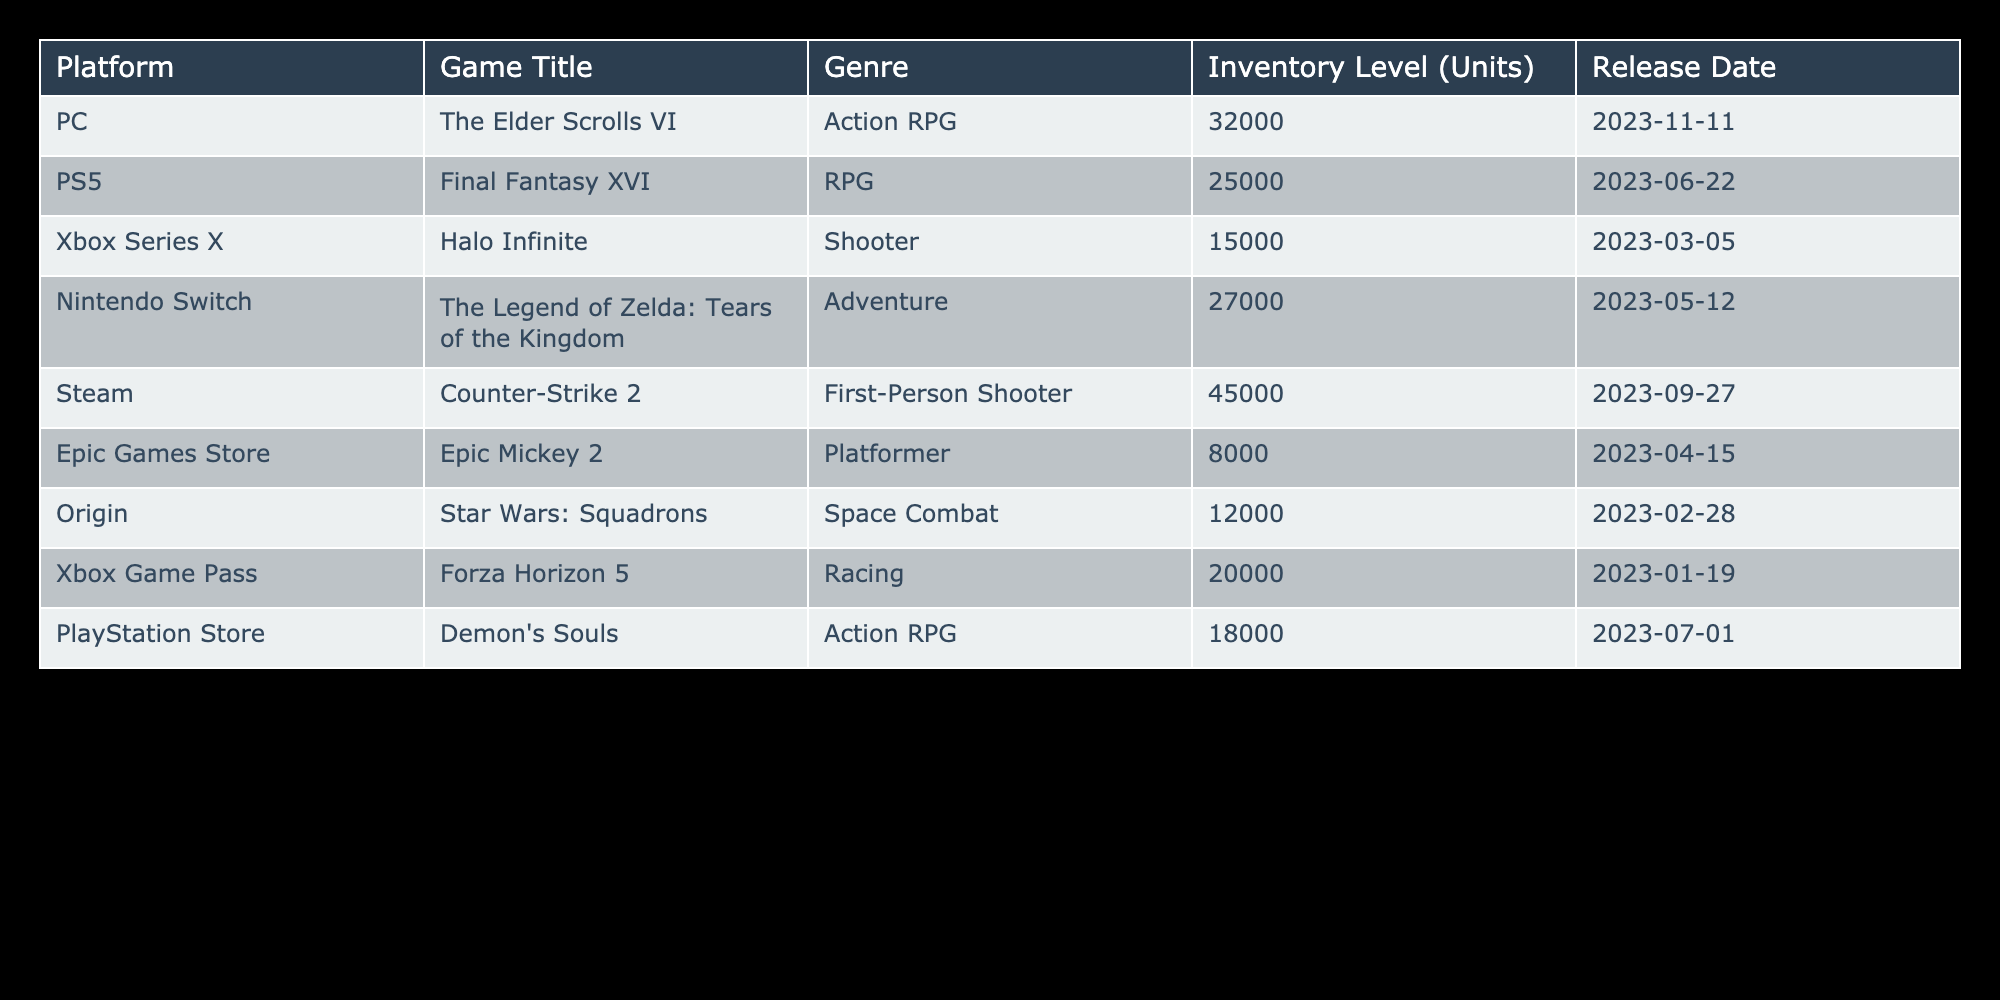What is the inventory level for the PC version of The Elder Scrolls VI? The inventory level for the PC version of The Elder Scrolls VI is found in the "Inventory Level (Units)" column next to its title. Referring to the table, the value listed is 32000 units.
Answer: 32000 Which game has the highest inventory level? To find the game with the highest inventory level, we can compare the values in the "Inventory Level (Units)" column. The highest value is 45000 for Counter-Strike 2.
Answer: Counter-Strike 2 What is the inventory level difference between Halo Infinite and Final Fantasy XVI? We need to subtract the inventory level of Final Fantasy XVI from that of Halo Infinite. Halo Infinite has 15000 units and Final Fantasy XVI has 25000 units. The difference is 15000 - 25000 = -10000. Since we measure difference in magnitude, we report it as 10000.
Answer: 10000 Are there more units of inventory for the Nintendo Switch title than for the PS5 title? Comparing the inventory levels of The Legend of Zelda: Tears of the Kingdom (27000) and Final Fantasy XVI (25000), we find that 27000 is greater than 25000, indicating that the inventory for the Switch title is higher.
Answer: Yes What is the average inventory level among the games released on Xbox platforms? To calculate the average inventory for Xbox titles, we first identify the Xbox games in the table: Halo Infinite (15000) and Forza Horizon 5 (20000). We sum these two values: 15000 + 20000 = 35000. Then we divide by the number of Xbox games (2) to find the average: 35000 / 2 = 17500.
Answer: 17500 Is the inventory level of Epic Mickey 2 above or below 10000 units? The inventory level for Epic Mickey 2 is listed as 8000 units in the table. Thus, it is below 10000.
Answer: Below Which genre has the least inventory in this table? We look through the inventory levels of each genre. Epic Mickey 2, as a platformer, has the lowest inventory at 8000 units compared to others listed.
Answer: Platformer If we combine the inventory levels of action RPGs and compare it to the total inventory of racing games, which is greater? First, we find the inventory for action RPGs: The Elder Scrolls VI (32000) and Demon's Souls (18000), which sums to 32000 + 18000 = 50000. For racing games, we only have Forza Horizon 5 with an inventory of 20000. Comparing the totals, 50000 is greater than 20000.
Answer: Action RPGs are greater 